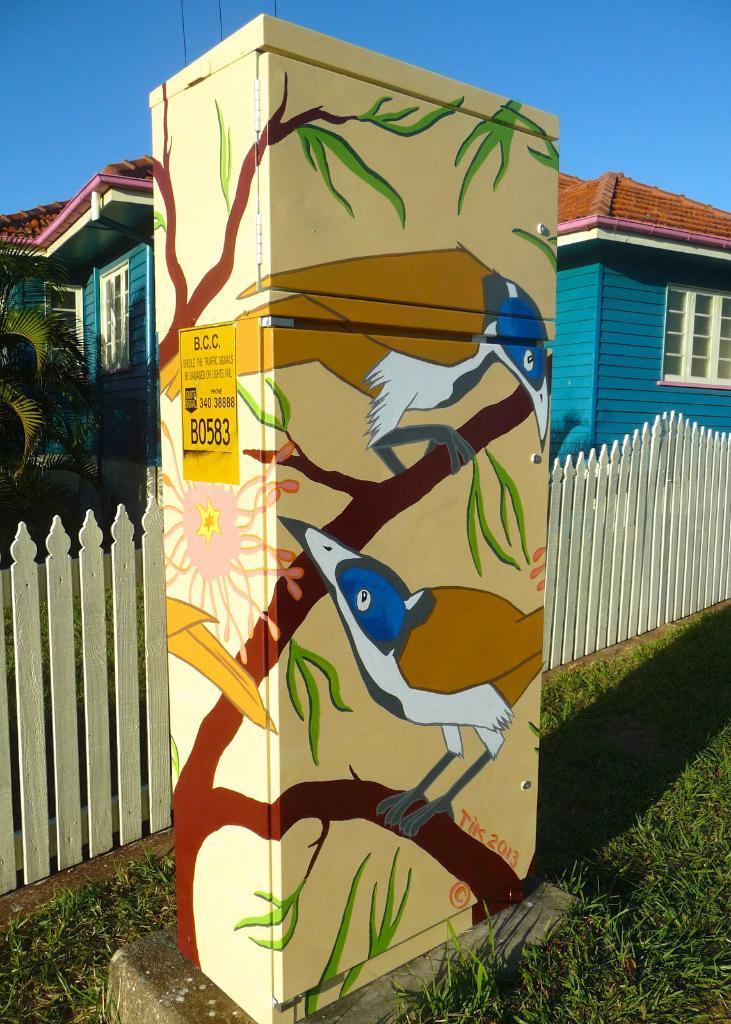In one or two sentences, can you explain what this image depicts? In this picture we can see a cabinet in the front, there is some text on the cabinet, at the bottom there is grass, we can see a house and plants in the middle, there is the sky at the top of the picture. 